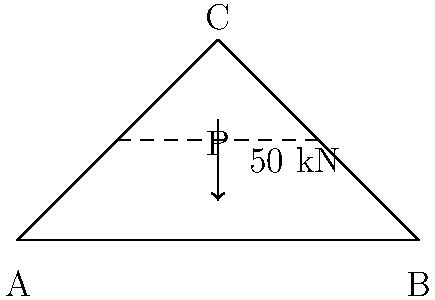A simple truss bridge is shown in the diagram above. The bridge is supported at points A and B, with a central peak at point C. A load of 50 kN is applied at point P, the midpoint of the bridge. Assuming the structure is symmetrical and ignoring the weight of the bridge itself, calculate the vertical reaction force at support A. To solve this problem, we'll use the principles of statics and moment equilibrium:

1) First, let's establish the equilibrium equations:
   
   Vertical force equilibrium: $R_A + R_B = 50$ kN
   
   Where $R_A$ and $R_B$ are the reaction forces at supports A and B respectively.

2) Due to symmetry, we know that $R_A = R_B$

3) Taking moments about point B:
   
   $R_A \cdot 100 - 50 \cdot 50 = 0$

4) Solving for $R_A$:
   
   $100R_A = 50 \cdot 50$
   $R_A = \frac{50 \cdot 50}{100} = 25$ kN

5) We can verify this by checking the vertical force equilibrium:
   
   $R_A + R_B = 25 + 25 = 50$ kN, which equals the applied load.

Therefore, the vertical reaction force at support A is 25 kN.
Answer: 25 kN 